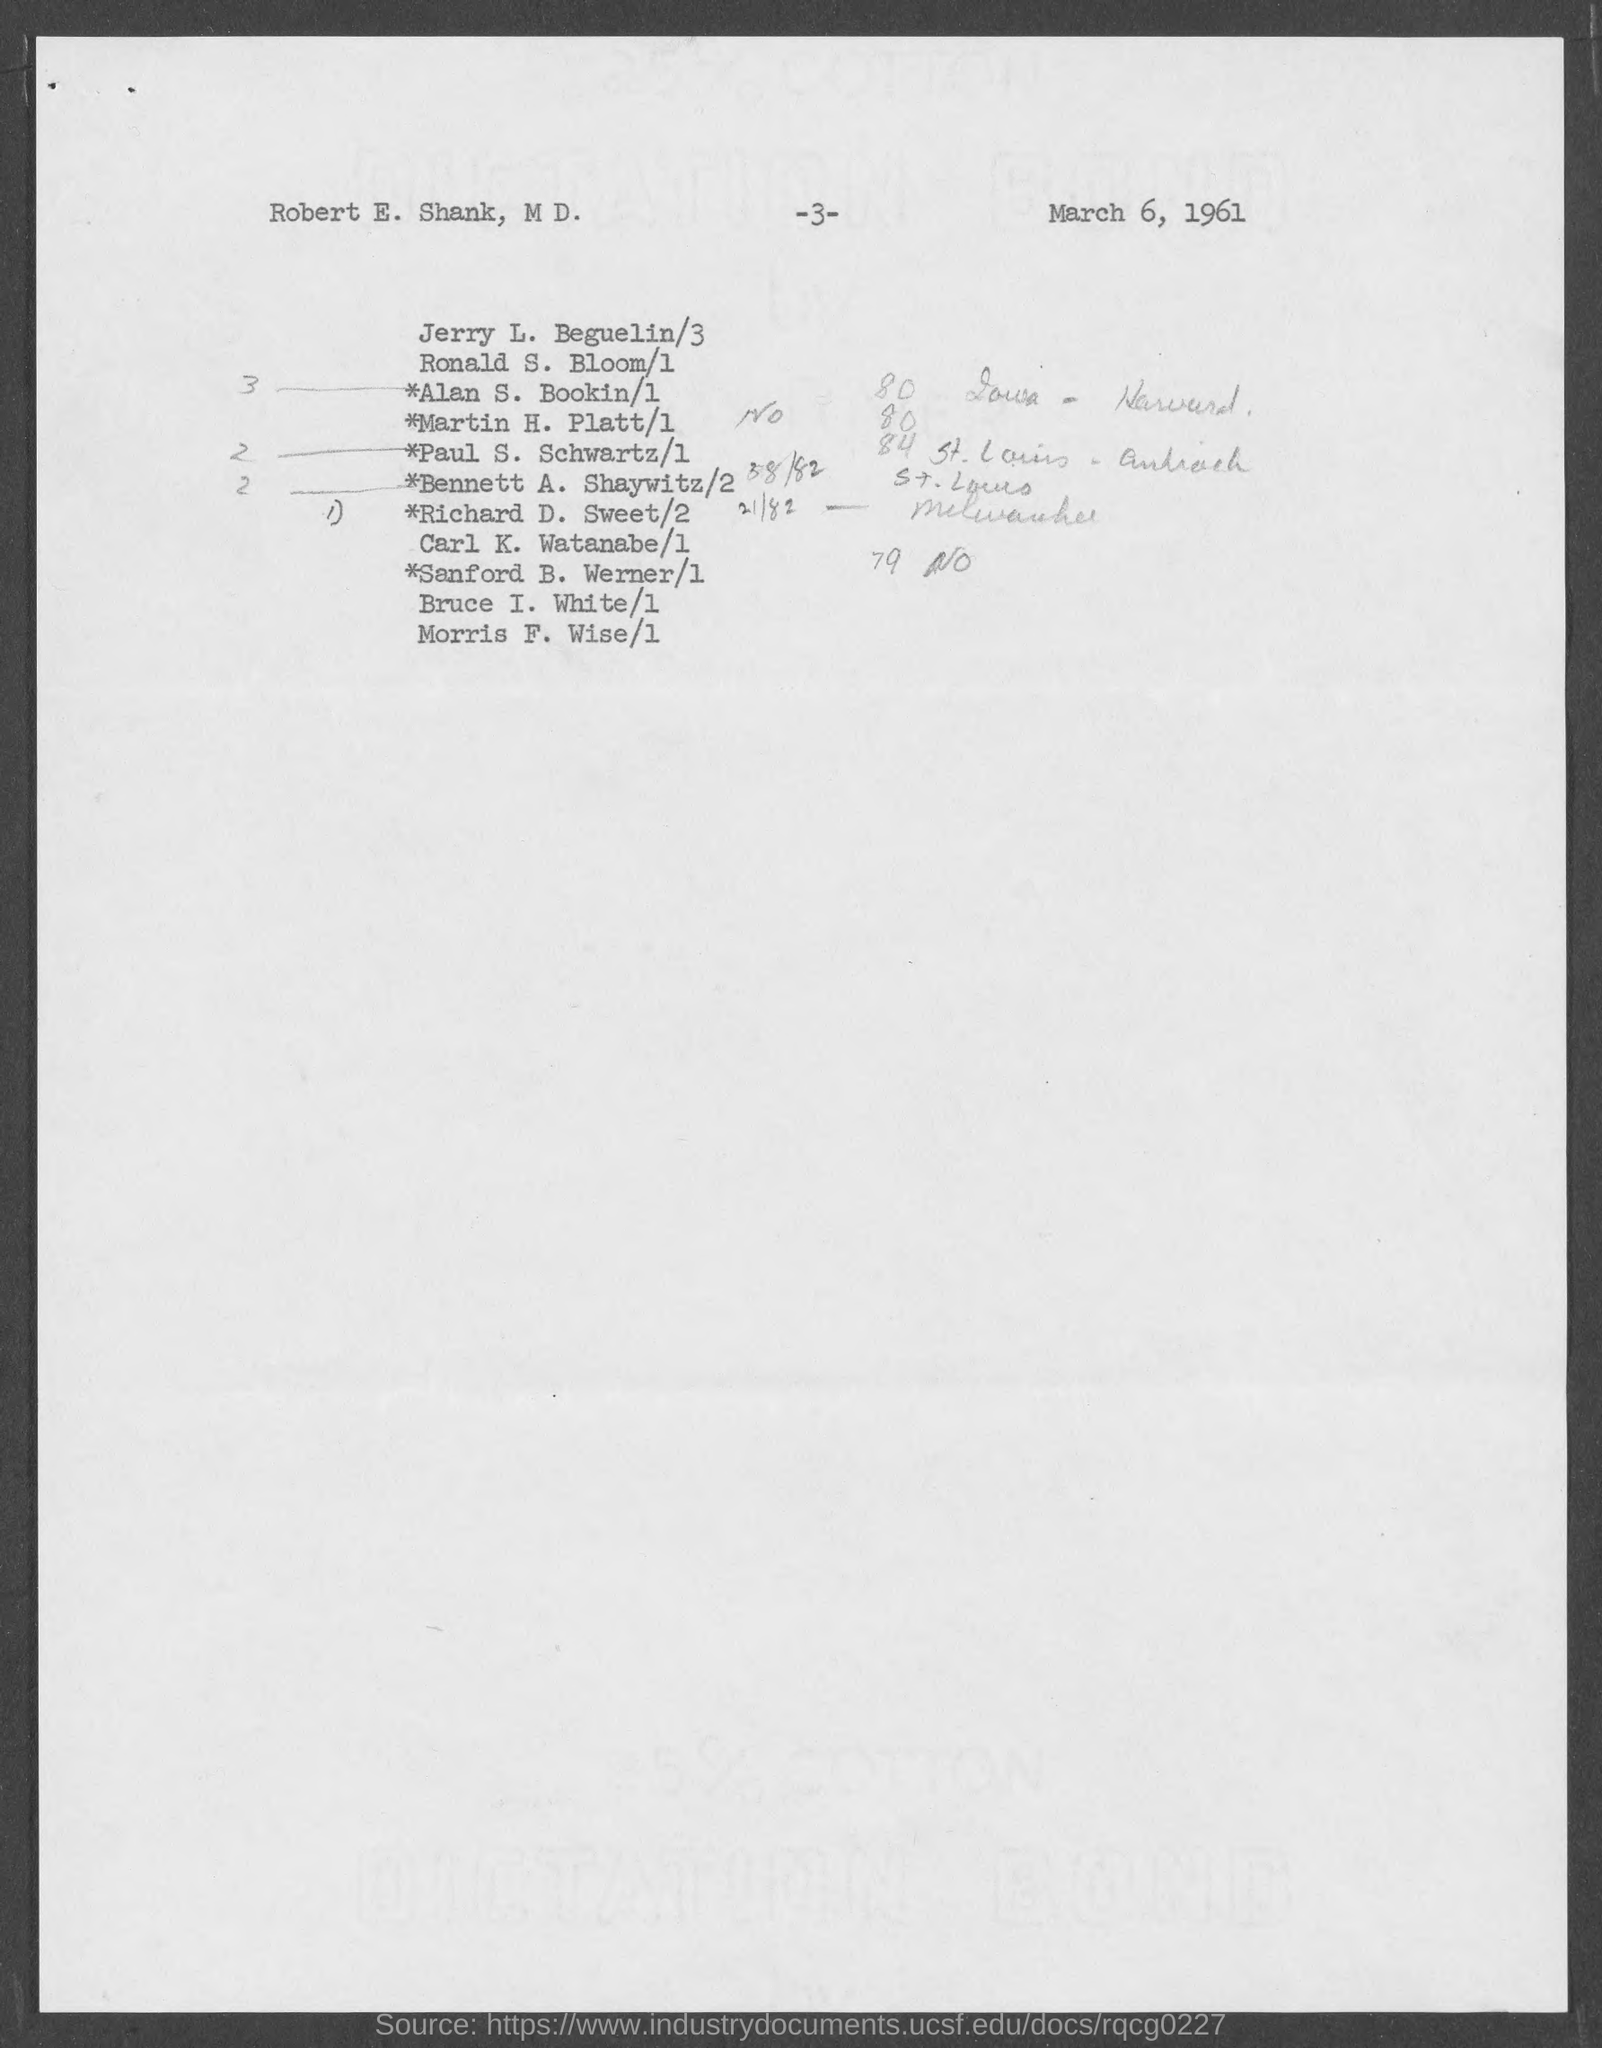Outline some significant characteristics in this image. The date mentioned in the document is March 6, 1961. What is the page number?" is a question that asks for information about a specific topic. The phrase "3.." is a continuation of the question, providing additional context and clarification. Together, the sentence can be restated as: "I am looking for the page number of a specific topic, and it is located on page 3 and possibly other pages as well. 